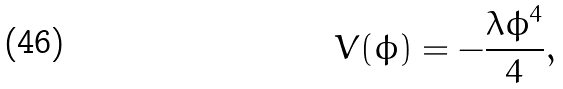Convert formula to latex. <formula><loc_0><loc_0><loc_500><loc_500>V ( \phi ) = - \frac { \lambda \phi ^ { 4 } } { 4 } ,</formula> 